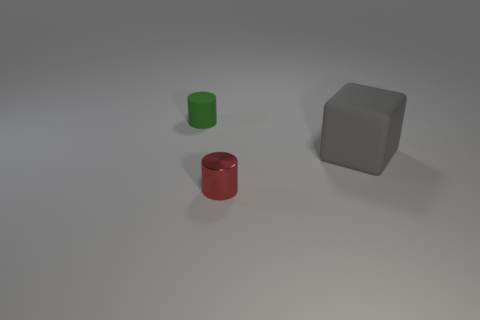Are there any other things that are made of the same material as the red cylinder?
Offer a very short reply. No. Does the small thing that is in front of the matte cube have the same material as the big gray thing?
Your response must be concise. No. There is a thing that is both to the right of the small matte thing and left of the gray object; what material is it?
Your answer should be compact. Metal. There is a thing that is right of the red thing; is it the same size as the metallic object?
Ensure brevity in your answer.  No. Is there any other thing that has the same size as the gray matte thing?
Your answer should be compact. No. Are there more big blocks right of the small red object than rubber cubes that are behind the green rubber thing?
Keep it short and to the point. Yes. The tiny thing that is behind the matte thing that is to the right of the cylinder that is behind the small red thing is what color?
Offer a terse response. Green. What number of things are gray objects or small metal things?
Your answer should be very brief. 2. What number of objects are either gray spheres or small cylinders behind the gray thing?
Make the answer very short. 1. Is the large gray thing made of the same material as the red cylinder?
Your response must be concise. No. 